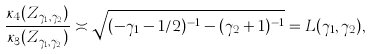<formula> <loc_0><loc_0><loc_500><loc_500>\frac { \kappa _ { 4 } ( Z _ { \gamma _ { 1 } , \gamma _ { 2 } } ) } { \kappa _ { 3 } ( Z _ { \gamma _ { 1 } , \gamma _ { 2 } } ) } \asymp \sqrt { ( - \gamma _ { 1 } - 1 / 2 ) ^ { - 1 } - ( \gamma _ { 2 } + 1 ) ^ { - 1 } } = L ( \gamma _ { 1 } , \gamma _ { 2 } ) ,</formula> 